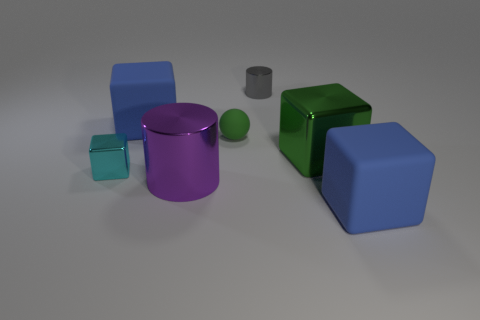Subtract all red spheres. How many blue cubes are left? 2 Subtract all tiny shiny cubes. How many cubes are left? 3 Subtract all cyan blocks. How many blocks are left? 3 Add 2 small red rubber balls. How many objects exist? 9 Subtract all red blocks. Subtract all green cylinders. How many blocks are left? 4 Subtract all cylinders. How many objects are left? 5 Add 4 big green spheres. How many big green spheres exist? 4 Subtract 0 gray balls. How many objects are left? 7 Subtract all shiny cylinders. Subtract all small green rubber things. How many objects are left? 4 Add 6 tiny metal blocks. How many tiny metal blocks are left? 7 